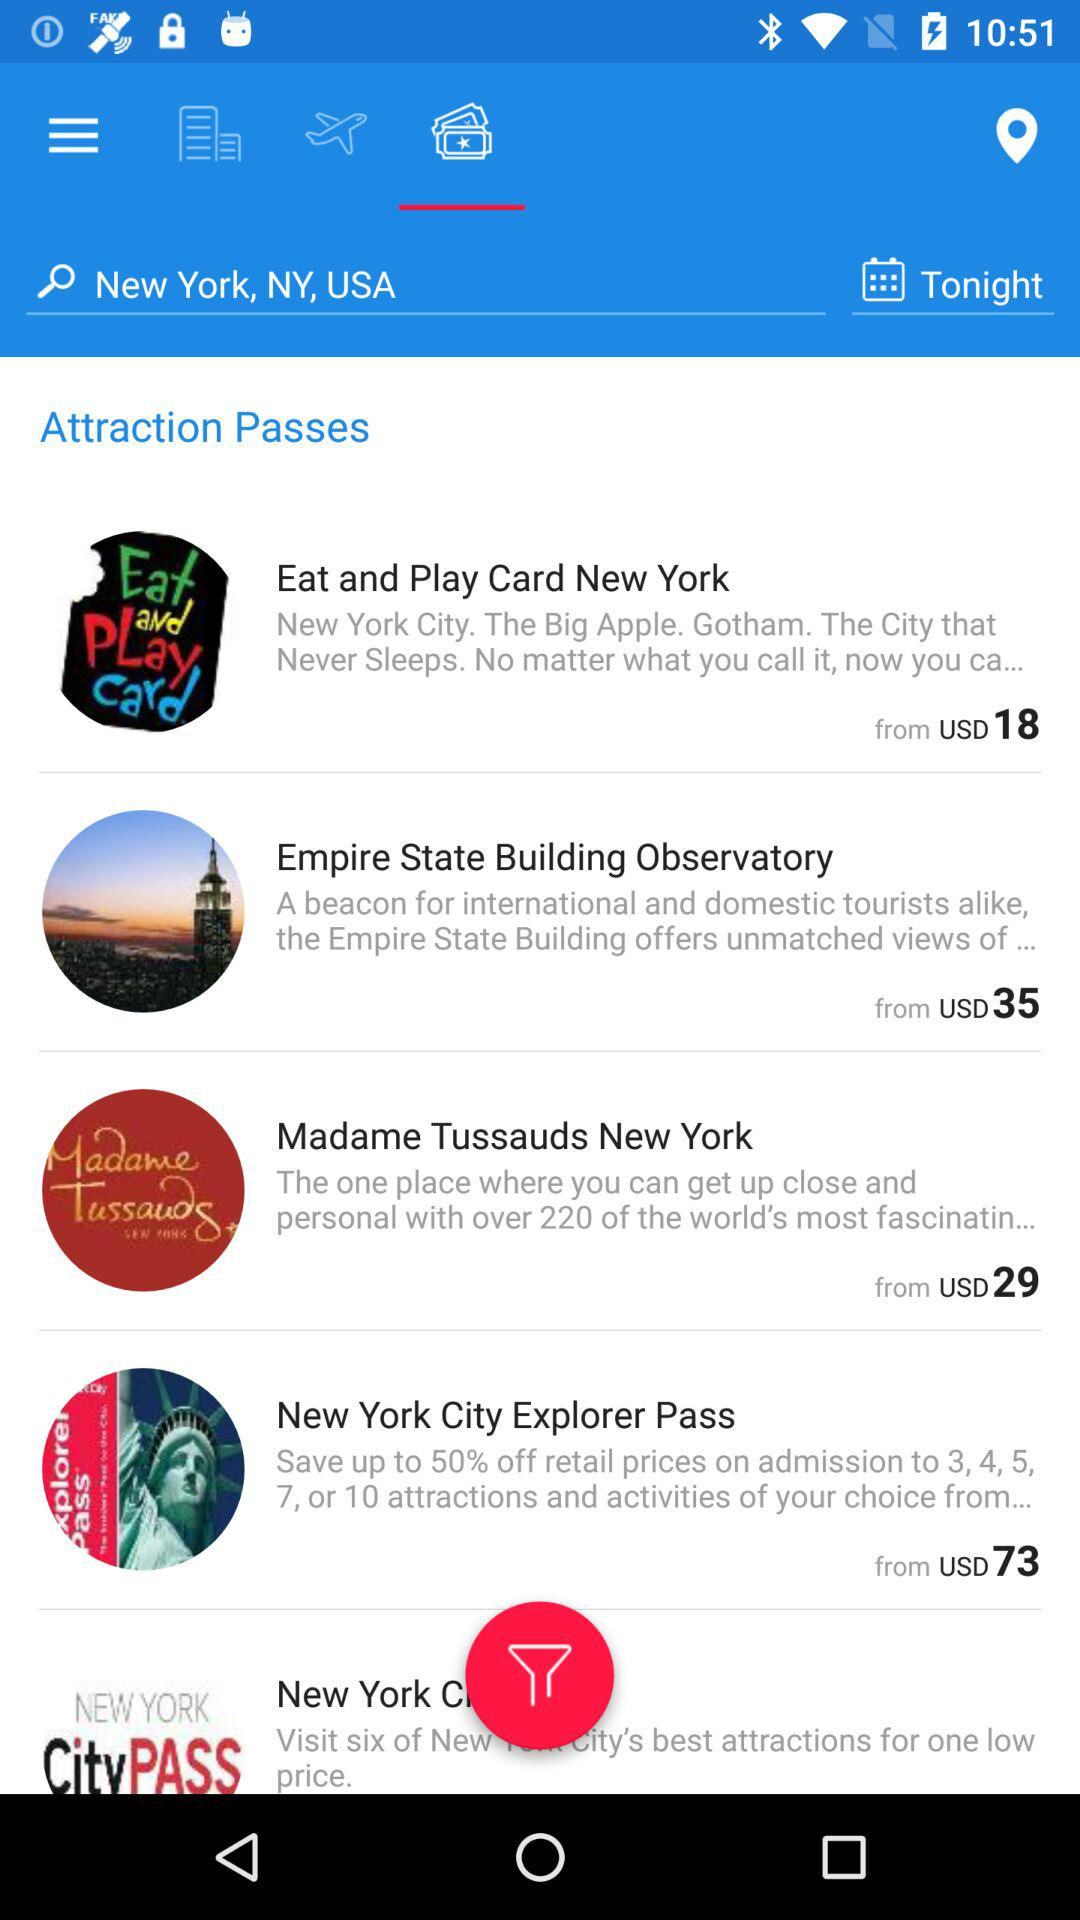What is the starting price of an "Eat and Play Card New York" pass? The starting price of an "Eat and Play Card New York" pass is USD 18. 